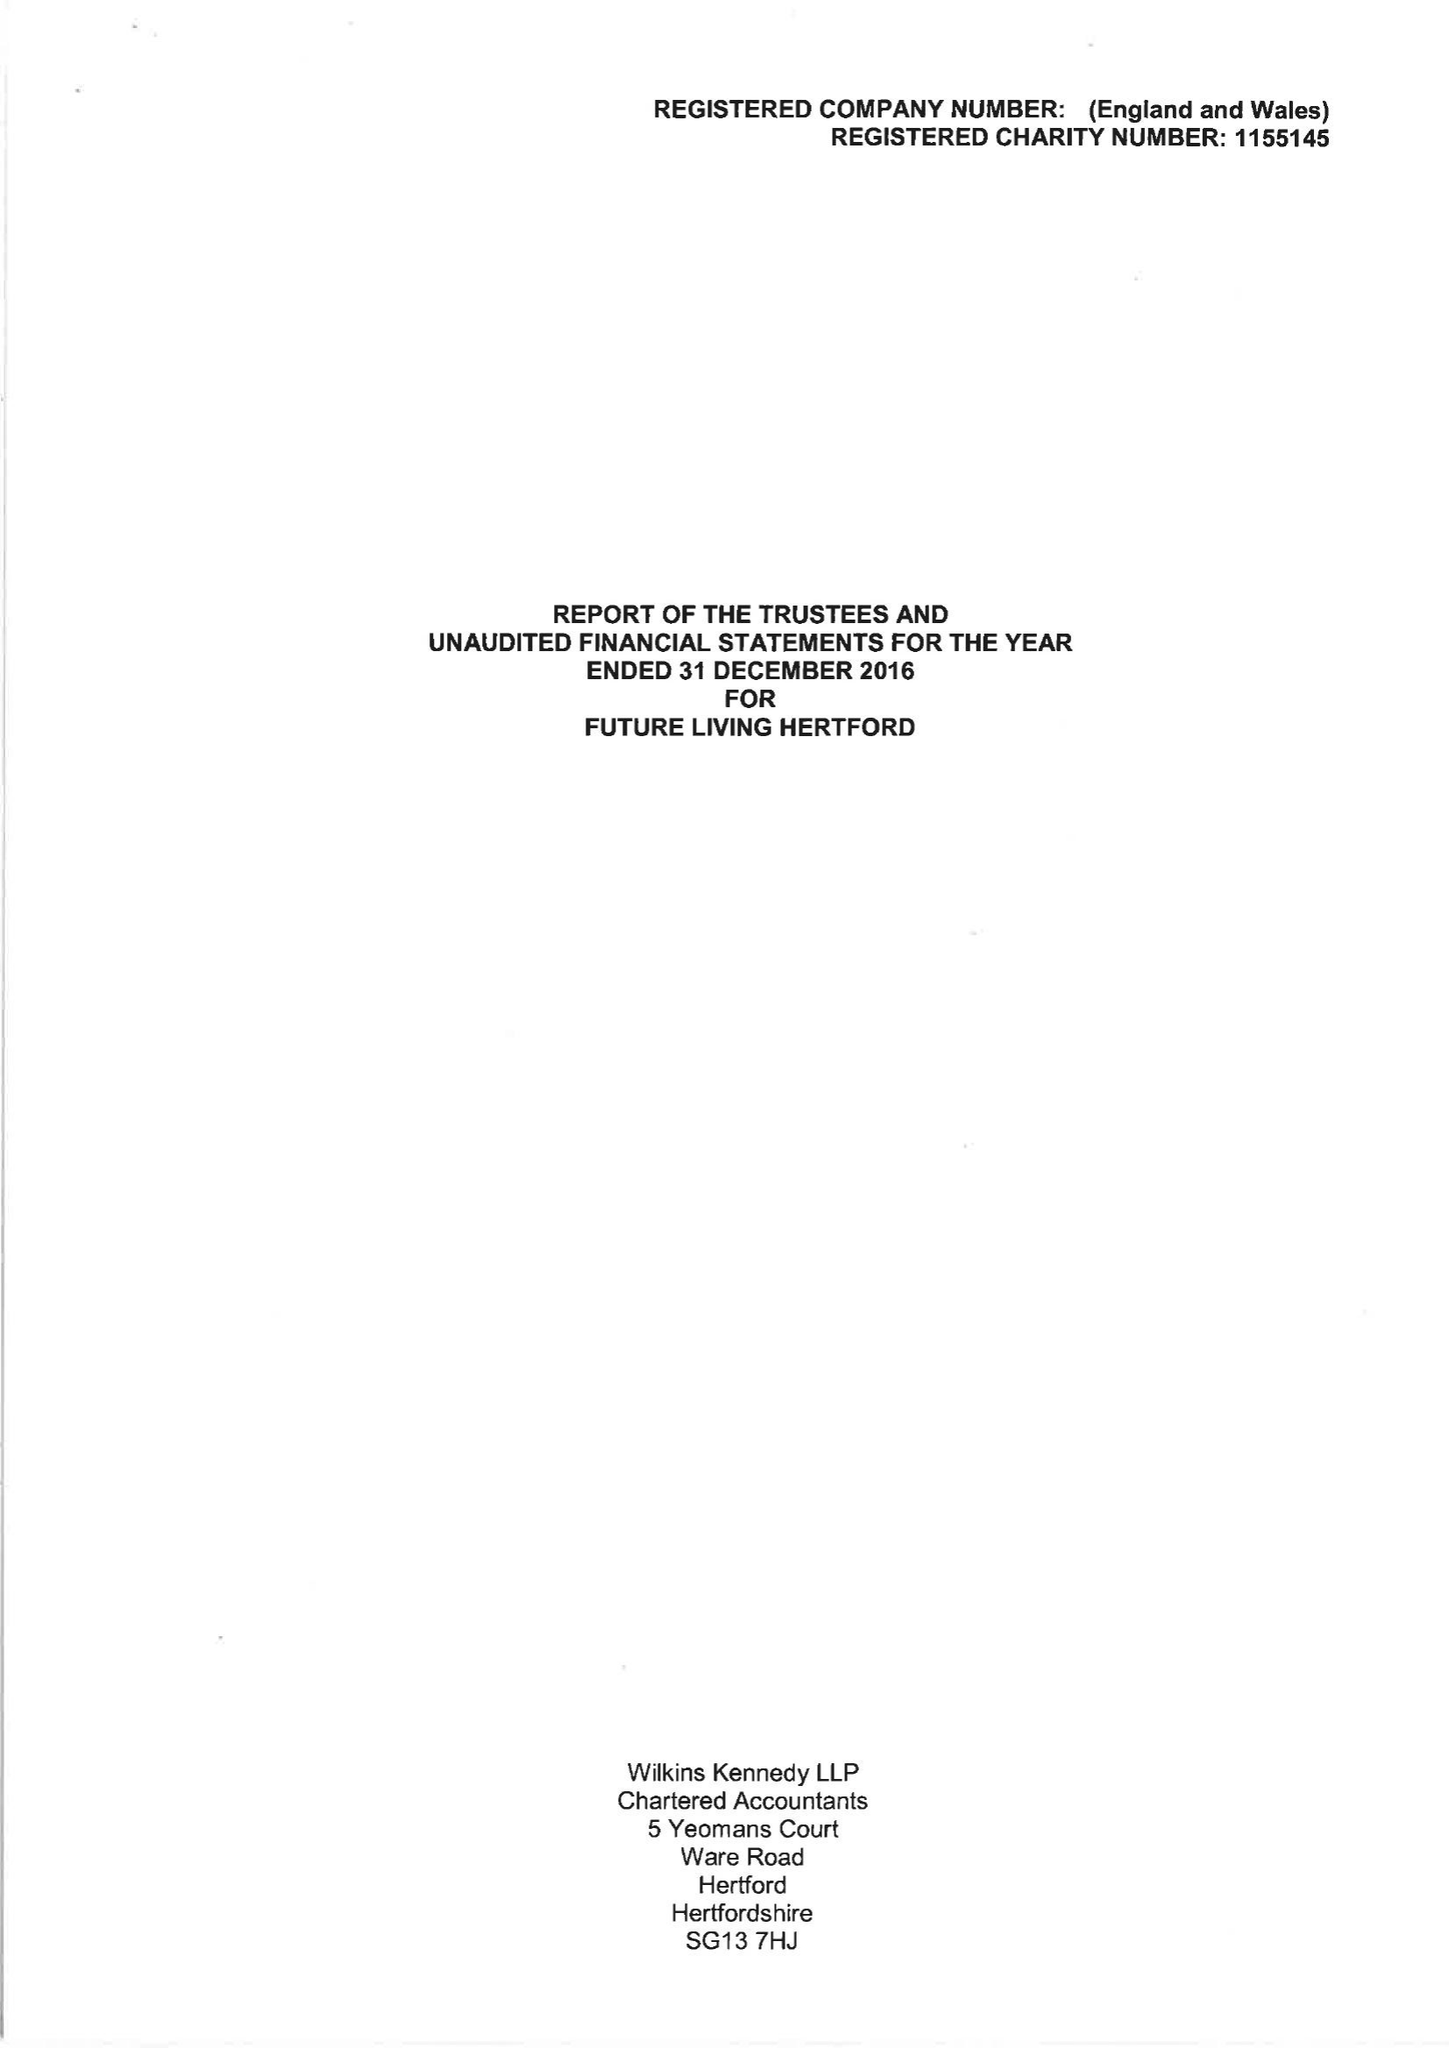What is the value for the report_date?
Answer the question using a single word or phrase. 2016-12-31 